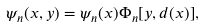Convert formula to latex. <formula><loc_0><loc_0><loc_500><loc_500>\psi _ { n } ( x , y ) = \psi _ { n } ( x ) \Phi _ { n } [ y , d ( x ) ] ,</formula> 